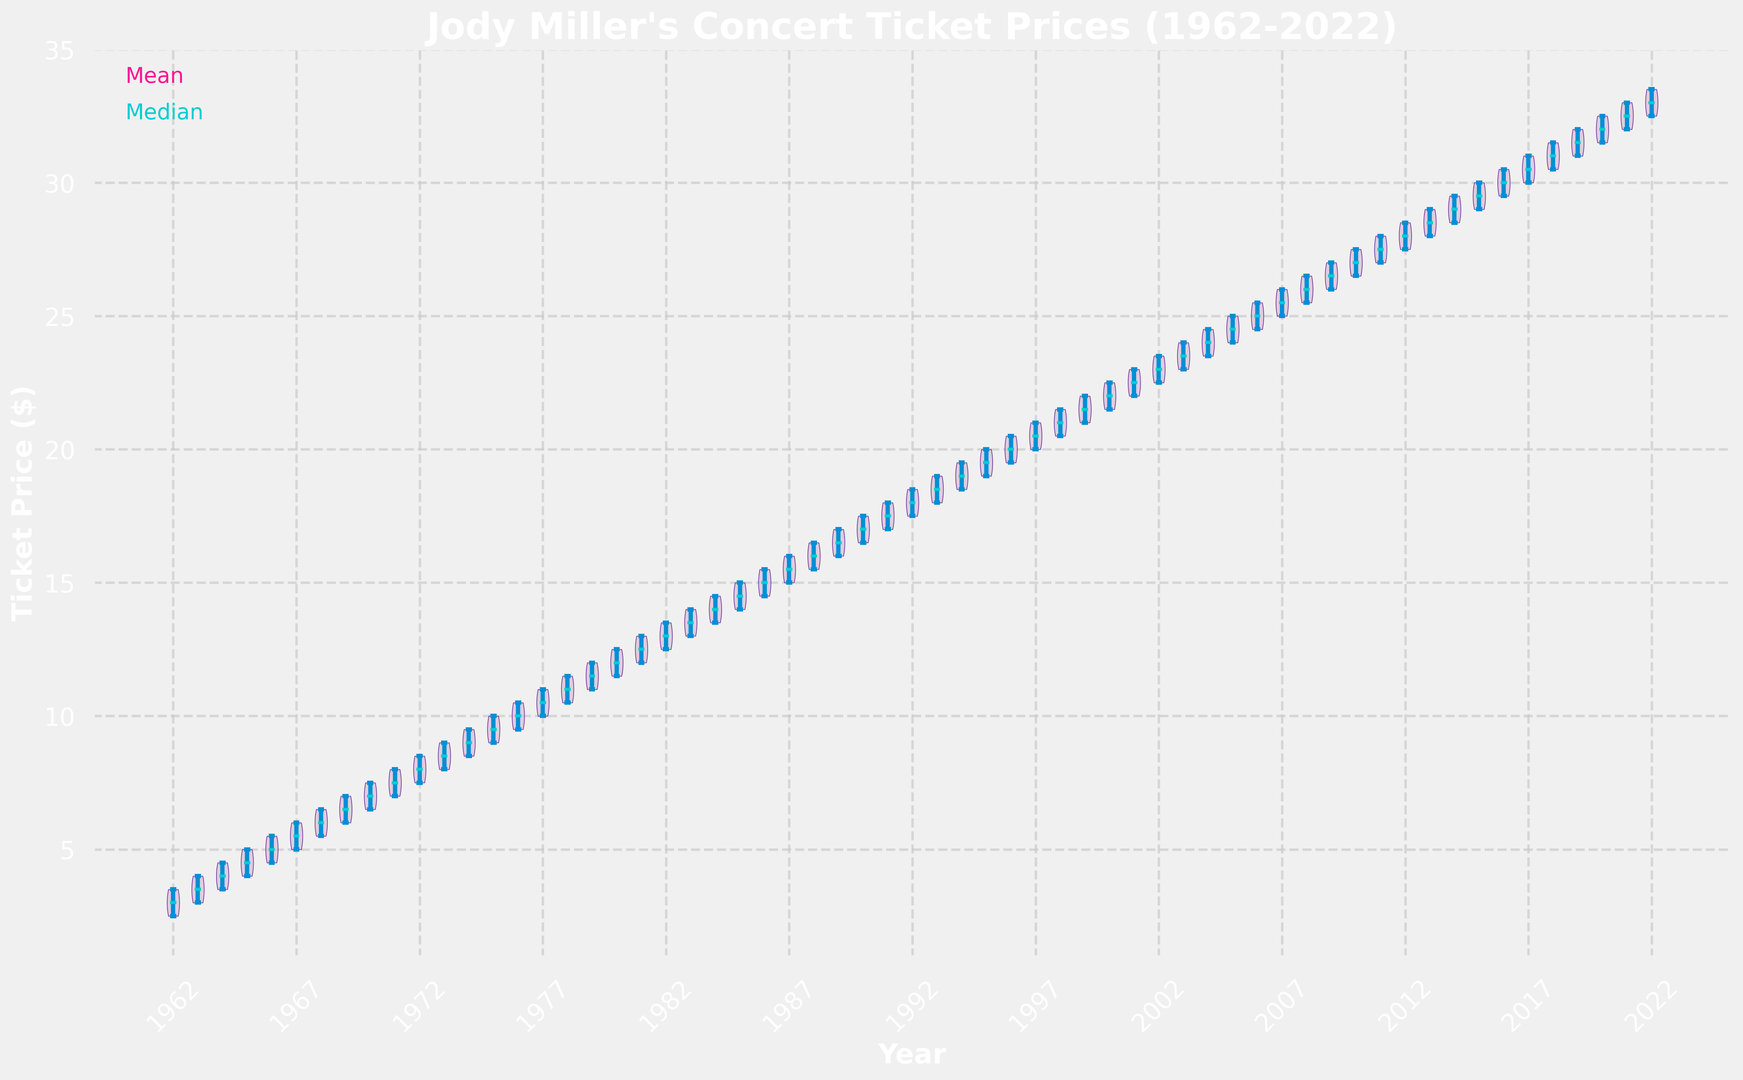What is the median ticket price in the year 1985? In the violin plot, the median is typically represented by a specific line inside the violin shape — in this case, it is labeled in a distinguishable color. Locate the median line for the year 1985.
Answer: 14.50 Did the mean ticket price increase or decrease from 1970 to 1980? The mean ticket price is indicated by a line in a specific color inside the violin plot. Compare the mean ticket price of 1970 and 1980 by observing the height of these lines for both years.
Answer: Increased Which year shows the highest variability in ticket prices? Variability in a violin plot can be estimated by the width of the violin. The year with the widest violin indicates the highest variability.
Answer: 2022 What is the mean ticket price in the year 2000? In the violin plot, the mean is marked by a specific color line through the center of each violin. Locate the mean line for the year 2000 and note its height on the y-axis.
Answer: 22.00 Between 1990 and 2000, in which year is the median ticket price the highest? Compare the median lines for each year between 1990 and 2000 (inclusive). The median is marked by a specific color line. Identify the year with the highest median line within this range.
Answer: 2000 By how much did the median ticket price change from 1975 to 1985? Identify the median ticket price for 1975 and 1985 using the specific median line indicator in the violin plot. Subtract the 1975 median from the 1985 median to get the change.
Answer: 5.00 Which year has a higher mean ticket price: 1995 or 2005? Compare the mean ticket prices indicated by the specific color lines inside the violins for 1995 and 2005. Identify which year has the higher line.
Answer: 2005 In which year does the violin plot indicate the lowest ticket price at the extremity? The extremities of the violin plot show the minimum and maximum ticket prices. Identify the year where the lower extremity of the violin plot is positioned closest to the y-axis's lowest values.
Answer: 1962 